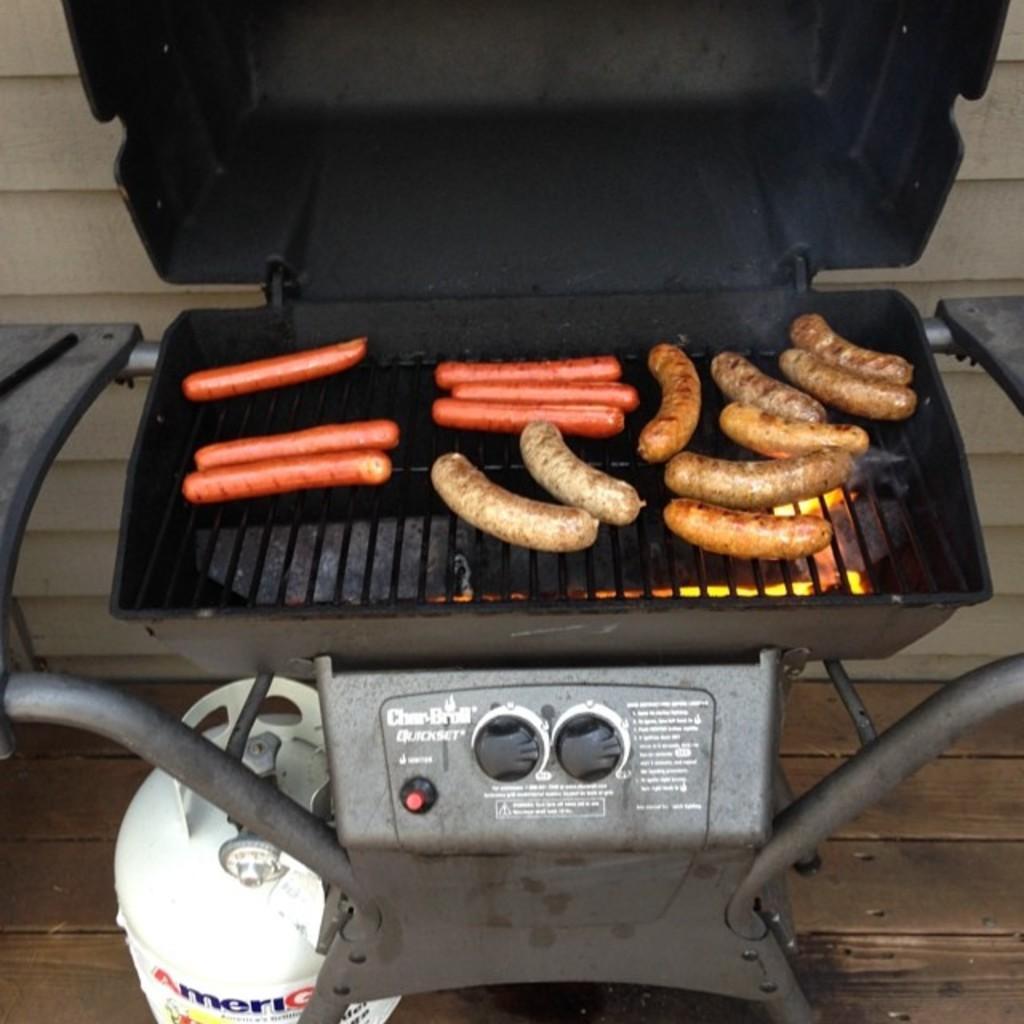In one or two sentences, can you explain what this image depicts? In this image, we can see a few hot dogs on the barbecue. Here we can see a rods and buttons. There is a white cylinder on the floor. Background there is a wall. 